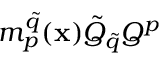Convert formula to latex. <formula><loc_0><loc_0><loc_500><loc_500>m _ { p } ^ { \tilde { q } } ( { x } ) \tilde { Q } _ { \tilde { q } } Q ^ { p }</formula> 